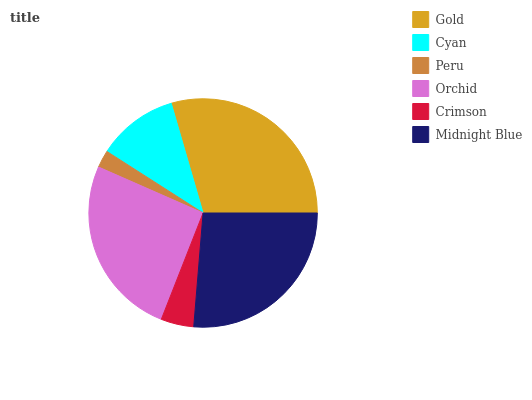Is Peru the minimum?
Answer yes or no. Yes. Is Gold the maximum?
Answer yes or no. Yes. Is Cyan the minimum?
Answer yes or no. No. Is Cyan the maximum?
Answer yes or no. No. Is Gold greater than Cyan?
Answer yes or no. Yes. Is Cyan less than Gold?
Answer yes or no. Yes. Is Cyan greater than Gold?
Answer yes or no. No. Is Gold less than Cyan?
Answer yes or no. No. Is Orchid the high median?
Answer yes or no. Yes. Is Cyan the low median?
Answer yes or no. Yes. Is Gold the high median?
Answer yes or no. No. Is Midnight Blue the low median?
Answer yes or no. No. 